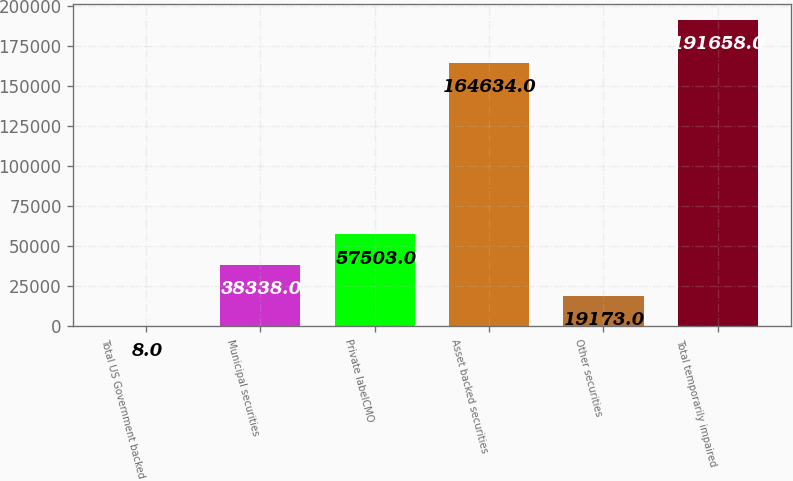Convert chart. <chart><loc_0><loc_0><loc_500><loc_500><bar_chart><fcel>Total US Government backed<fcel>Municipal securities<fcel>Private labelCMO<fcel>Asset backed securities<fcel>Other securities<fcel>Total temporarily impaired<nl><fcel>8<fcel>38338<fcel>57503<fcel>164634<fcel>19173<fcel>191658<nl></chart> 